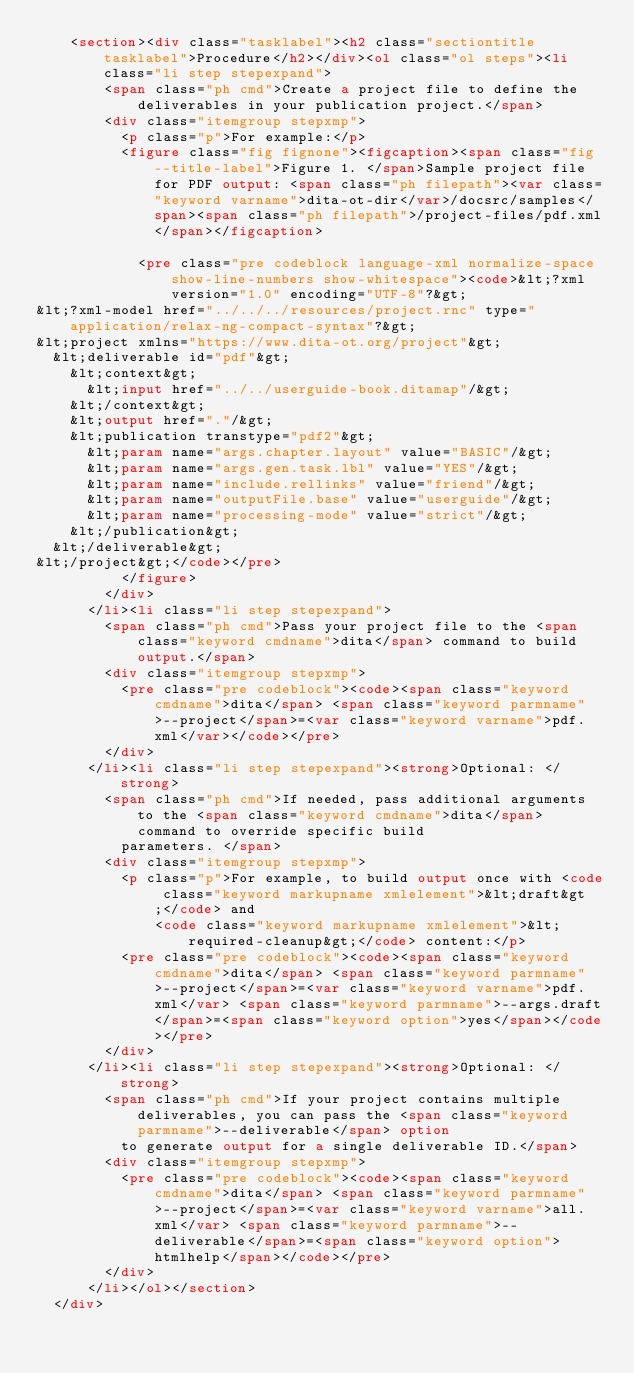Convert code to text. <code><loc_0><loc_0><loc_500><loc_500><_HTML_>    <section><div class="tasklabel"><h2 class="sectiontitle tasklabel">Procedure</h2></div><ol class="ol steps"><li class="li step stepexpand">
        <span class="ph cmd">Create a project file to define the deliverables in your publication project.</span>
        <div class="itemgroup stepxmp">
          <p class="p">For example:</p>
          <figure class="fig fignone"><figcaption><span class="fig--title-label">Figure 1. </span>Sample project file for PDF output: <span class="ph filepath"><var class="keyword varname">dita-ot-dir</var>/docsrc/samples</span><span class="ph filepath">/project-files/pdf.xml</span></figcaption>
            
            <pre class="pre codeblock language-xml normalize-space show-line-numbers show-whitespace"><code>&lt;?xml version="1.0" encoding="UTF-8"?&gt;
&lt;?xml-model href="../../../resources/project.rnc" type="application/relax-ng-compact-syntax"?&gt;
&lt;project xmlns="https://www.dita-ot.org/project"&gt;
  &lt;deliverable id="pdf"&gt;
    &lt;context&gt;
      &lt;input href="../../userguide-book.ditamap"/&gt;
    &lt;/context&gt;
    &lt;output href="."/&gt;
    &lt;publication transtype="pdf2"&gt;
      &lt;param name="args.chapter.layout" value="BASIC"/&gt;
      &lt;param name="args.gen.task.lbl" value="YES"/&gt;
      &lt;param name="include.rellinks" value="friend"/&gt;
      &lt;param name="outputFile.base" value="userguide"/&gt;
      &lt;param name="processing-mode" value="strict"/&gt;
    &lt;/publication&gt;
  &lt;/deliverable&gt;
&lt;/project&gt;</code></pre>
          </figure>
        </div>
      </li><li class="li step stepexpand">
        <span class="ph cmd">Pass your project file to the <span class="keyword cmdname">dita</span> command to build output.</span>
        <div class="itemgroup stepxmp">
          <pre class="pre codeblock"><code><span class="keyword cmdname">dita</span> <span class="keyword parmname">--project</span>=<var class="keyword varname">pdf.xml</var></code></pre>
        </div>
      </li><li class="li step stepexpand"><strong>Optional: </strong>
        <span class="ph cmd">If needed, pass additional arguments to the <span class="keyword cmdname">dita</span> command to override specific build
          parameters. </span>
        <div class="itemgroup stepxmp">
          <p class="p">For example, to build output once with <code class="keyword markupname xmlelement">&lt;draft&gt;</code> and
              <code class="keyword markupname xmlelement">&lt;required-cleanup&gt;</code> content:</p>
          <pre class="pre codeblock"><code><span class="keyword cmdname">dita</span> <span class="keyword parmname">--project</span>=<var class="keyword varname">pdf.xml</var> <span class="keyword parmname">--args.draft</span>=<span class="keyword option">yes</span></code></pre>
        </div>
      </li><li class="li step stepexpand"><strong>Optional: </strong>
        <span class="ph cmd">If your project contains multiple deliverables, you can pass the <span class="keyword parmname">--deliverable</span> option
          to generate output for a single deliverable ID.</span>
        <div class="itemgroup stepxmp">
          <pre class="pre codeblock"><code><span class="keyword cmdname">dita</span> <span class="keyword parmname">--project</span>=<var class="keyword varname">all.xml</var> <span class="keyword parmname">--deliverable</span>=<span class="keyword option">htmlhelp</span></code></pre>
        </div>
      </li></ol></section>
  </div></code> 